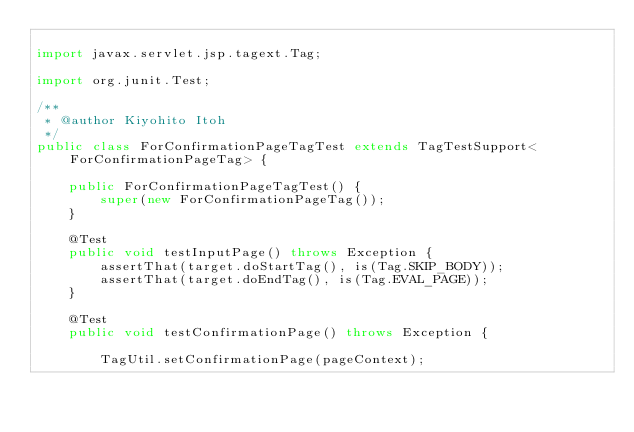<code> <loc_0><loc_0><loc_500><loc_500><_Java_>
import javax.servlet.jsp.tagext.Tag;

import org.junit.Test;

/**
 * @author Kiyohito Itoh
 */
public class ForConfirmationPageTagTest extends TagTestSupport<ForConfirmationPageTag> {
    
    public ForConfirmationPageTagTest() {
        super(new ForConfirmationPageTag());
    }
    
    @Test
    public void testInputPage() throws Exception {
        assertThat(target.doStartTag(), is(Tag.SKIP_BODY));
        assertThat(target.doEndTag(), is(Tag.EVAL_PAGE));
    }
    
    @Test
    public void testConfirmationPage() throws Exception {
        
        TagUtil.setConfirmationPage(pageContext);
        </code> 